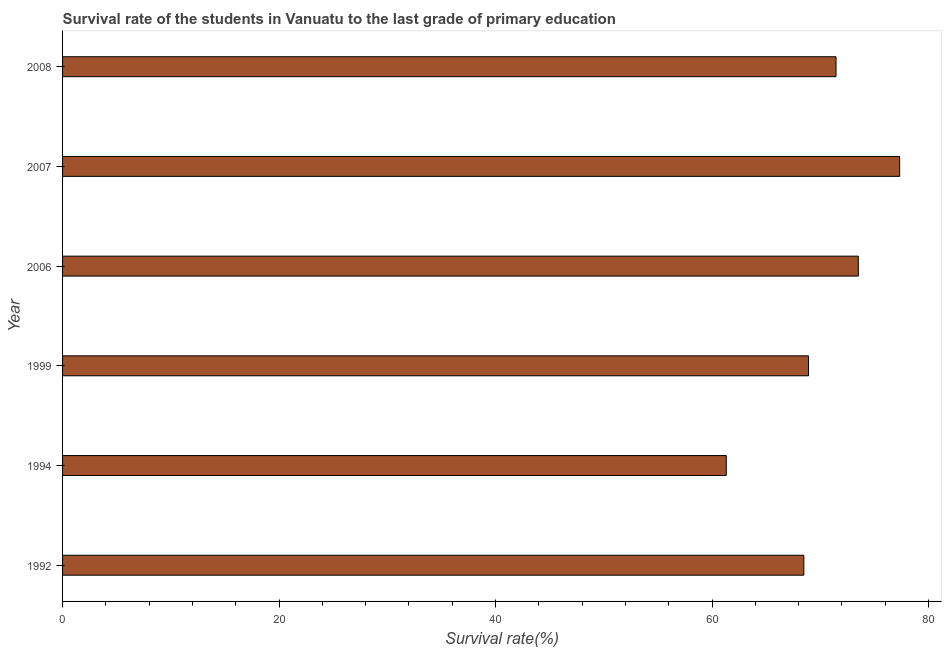Does the graph contain any zero values?
Ensure brevity in your answer.  No. What is the title of the graph?
Ensure brevity in your answer.  Survival rate of the students in Vanuatu to the last grade of primary education. What is the label or title of the X-axis?
Provide a short and direct response. Survival rate(%). What is the label or title of the Y-axis?
Provide a short and direct response. Year. What is the survival rate in primary education in 2007?
Provide a succinct answer. 77.33. Across all years, what is the maximum survival rate in primary education?
Keep it short and to the point. 77.33. Across all years, what is the minimum survival rate in primary education?
Ensure brevity in your answer.  61.31. In which year was the survival rate in primary education minimum?
Your response must be concise. 1994. What is the sum of the survival rate in primary education?
Provide a short and direct response. 421. What is the difference between the survival rate in primary education in 1994 and 2006?
Give a very brief answer. -12.2. What is the average survival rate in primary education per year?
Offer a very short reply. 70.17. What is the median survival rate in primary education?
Your answer should be compact. 70.18. In how many years, is the survival rate in primary education greater than 20 %?
Provide a succinct answer. 6. What is the ratio of the survival rate in primary education in 2007 to that in 2008?
Offer a terse response. 1.08. Is the difference between the survival rate in primary education in 1999 and 2007 greater than the difference between any two years?
Offer a terse response. No. What is the difference between the highest and the second highest survival rate in primary education?
Provide a succinct answer. 3.82. What is the difference between the highest and the lowest survival rate in primary education?
Offer a very short reply. 16.02. In how many years, is the survival rate in primary education greater than the average survival rate in primary education taken over all years?
Give a very brief answer. 3. Are all the bars in the graph horizontal?
Your answer should be compact. Yes. What is the difference between two consecutive major ticks on the X-axis?
Give a very brief answer. 20. Are the values on the major ticks of X-axis written in scientific E-notation?
Provide a short and direct response. No. What is the Survival rate(%) of 1992?
Your answer should be very brief. 68.48. What is the Survival rate(%) in 1994?
Ensure brevity in your answer.  61.31. What is the Survival rate(%) in 1999?
Ensure brevity in your answer.  68.91. What is the Survival rate(%) in 2006?
Offer a very short reply. 73.51. What is the Survival rate(%) in 2007?
Your response must be concise. 77.33. What is the Survival rate(%) in 2008?
Provide a short and direct response. 71.45. What is the difference between the Survival rate(%) in 1992 and 1994?
Provide a succinct answer. 7.17. What is the difference between the Survival rate(%) in 1992 and 1999?
Provide a short and direct response. -0.43. What is the difference between the Survival rate(%) in 1992 and 2006?
Provide a short and direct response. -5.03. What is the difference between the Survival rate(%) in 1992 and 2007?
Your response must be concise. -8.85. What is the difference between the Survival rate(%) in 1992 and 2008?
Make the answer very short. -2.97. What is the difference between the Survival rate(%) in 1994 and 1999?
Your answer should be very brief. -7.6. What is the difference between the Survival rate(%) in 1994 and 2006?
Your response must be concise. -12.2. What is the difference between the Survival rate(%) in 1994 and 2007?
Your response must be concise. -16.02. What is the difference between the Survival rate(%) in 1994 and 2008?
Give a very brief answer. -10.14. What is the difference between the Survival rate(%) in 1999 and 2006?
Your answer should be very brief. -4.6. What is the difference between the Survival rate(%) in 1999 and 2007?
Provide a succinct answer. -8.42. What is the difference between the Survival rate(%) in 1999 and 2008?
Provide a succinct answer. -2.54. What is the difference between the Survival rate(%) in 2006 and 2007?
Keep it short and to the point. -3.82. What is the difference between the Survival rate(%) in 2006 and 2008?
Ensure brevity in your answer.  2.06. What is the difference between the Survival rate(%) in 2007 and 2008?
Ensure brevity in your answer.  5.88. What is the ratio of the Survival rate(%) in 1992 to that in 1994?
Provide a succinct answer. 1.12. What is the ratio of the Survival rate(%) in 1992 to that in 1999?
Ensure brevity in your answer.  0.99. What is the ratio of the Survival rate(%) in 1992 to that in 2006?
Ensure brevity in your answer.  0.93. What is the ratio of the Survival rate(%) in 1992 to that in 2007?
Your response must be concise. 0.89. What is the ratio of the Survival rate(%) in 1992 to that in 2008?
Offer a very short reply. 0.96. What is the ratio of the Survival rate(%) in 1994 to that in 1999?
Ensure brevity in your answer.  0.89. What is the ratio of the Survival rate(%) in 1994 to that in 2006?
Provide a short and direct response. 0.83. What is the ratio of the Survival rate(%) in 1994 to that in 2007?
Your answer should be compact. 0.79. What is the ratio of the Survival rate(%) in 1994 to that in 2008?
Your answer should be very brief. 0.86. What is the ratio of the Survival rate(%) in 1999 to that in 2006?
Give a very brief answer. 0.94. What is the ratio of the Survival rate(%) in 1999 to that in 2007?
Make the answer very short. 0.89. What is the ratio of the Survival rate(%) in 2006 to that in 2007?
Ensure brevity in your answer.  0.95. What is the ratio of the Survival rate(%) in 2007 to that in 2008?
Your answer should be very brief. 1.08. 